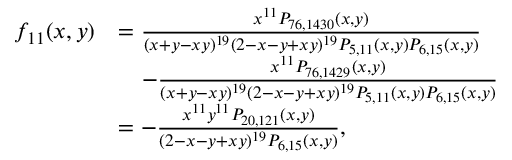<formula> <loc_0><loc_0><loc_500><loc_500>\begin{array} { r l } { f _ { 1 1 } ( x , y ) } & { = \frac { x ^ { 1 1 } P _ { 7 6 , 1 4 3 0 } ( x , y ) } { ( x + y - x y ) ^ { 1 9 } ( 2 - x - y + x y ) ^ { 1 9 } P _ { 5 , 1 1 } ( x , y ) P _ { 6 , 1 5 } ( x , y ) } } \\ & { \quad - \frac { x ^ { 1 1 } P _ { 7 6 , 1 4 2 9 } ( x , y ) } { ( x + y - x y ) ^ { 1 9 } ( 2 - x - y + x y ) ^ { 1 9 } P _ { 5 , 1 1 } ( x , y ) P _ { 6 , 1 5 } ( x , y ) } } \\ & { = - \frac { x ^ { 1 1 } y ^ { 1 1 } P _ { 2 0 , 1 2 1 } ( x , y ) } { ( 2 - x - y + x y ) ^ { 1 9 } P _ { 6 , 1 5 } ( x , y ) } , } \end{array}</formula> 